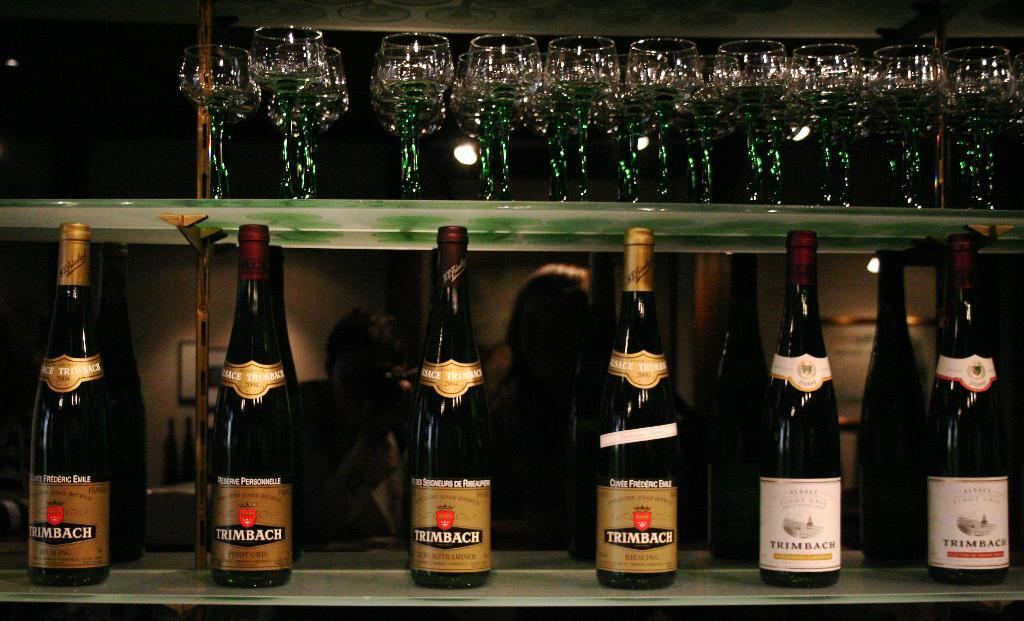<image>
Present a compact description of the photo's key features. A row of liquor bottles with the brand name TRIMBACH sitting on a bar. 